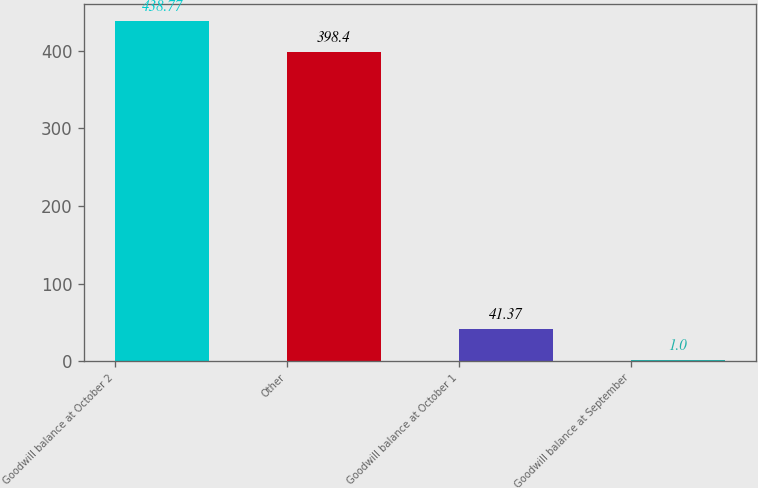Convert chart. <chart><loc_0><loc_0><loc_500><loc_500><bar_chart><fcel>Goodwill balance at October 2<fcel>Other<fcel>Goodwill balance at October 1<fcel>Goodwill balance at September<nl><fcel>438.77<fcel>398.4<fcel>41.37<fcel>1<nl></chart> 